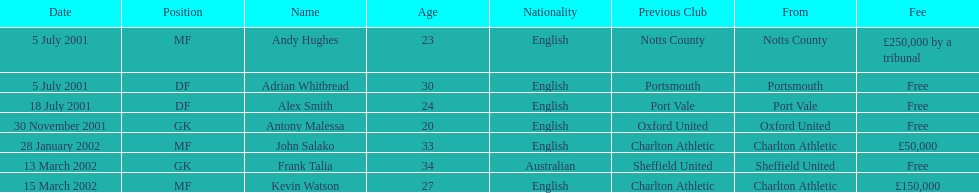Parse the table in full. {'header': ['Date', 'Position', 'Name', 'Age', 'Nationality', 'Previous Club', 'From', 'Fee'], 'rows': [['5 July 2001', 'MF', 'Andy Hughes', '23', 'English', 'Notts County', 'Notts County', '£250,000 by a tribunal'], ['5 July 2001', 'DF', 'Adrian Whitbread', '30', 'English', 'Portsmouth', 'Portsmouth', 'Free'], ['18 July 2001', 'DF', 'Alex Smith', '24', 'English', 'Port Vale', 'Port Vale', 'Free'], ['30 November 2001', 'GK', 'Antony Malessa', '20', 'English', 'Oxford United', 'Oxford United', 'Free'], ['28 January 2002', 'MF', 'John Salako', '33', 'English', 'Charlton Athletic', 'Charlton Athletic', '£50,000'], ['13 March 2002', 'GK', 'Frank Talia', '34', 'Australian', 'Sheffield United', 'Sheffield United', 'Free'], ['15 March 2002', 'MF', 'Kevin Watson', '27', 'English', 'Charlton Athletic', 'Charlton Athletic', '£150,000']]} Who transferred after 30 november 2001? John Salako, Frank Talia, Kevin Watson. 